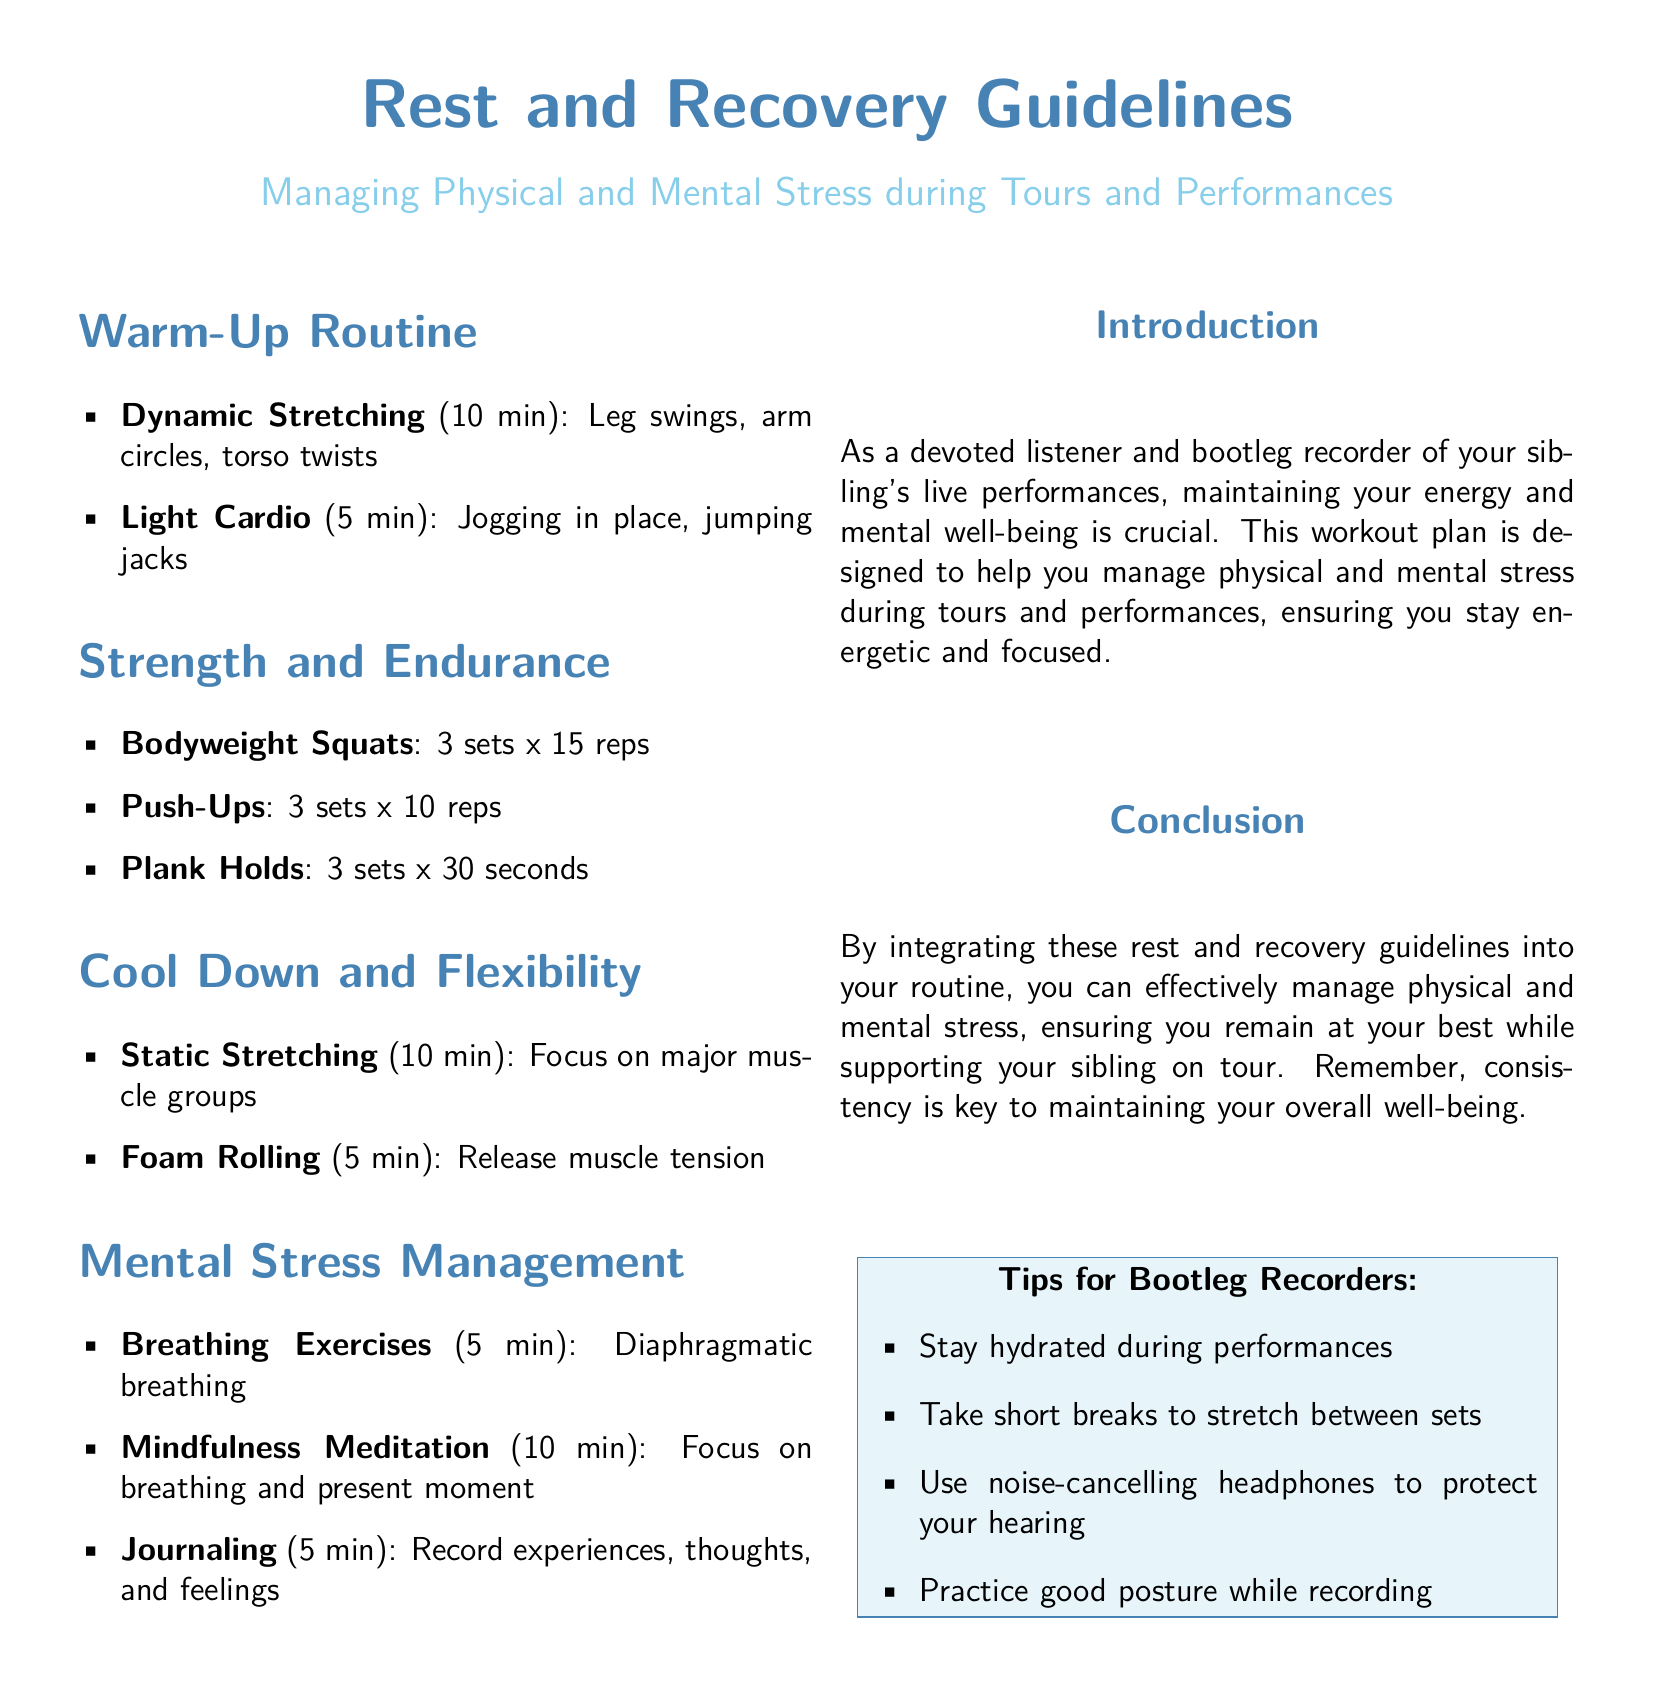What is the total time for the warm-up routine? The warm-up routine consists of 10 minutes for dynamic stretching and 5 minutes for light cardio, totaling 15 minutes.
Answer: 15 min How many sets of bodyweight squats are recommended? The document specifically states to perform 3 sets of bodyweight squats.
Answer: 3 sets What breathing technique is included in mental stress management? Diaphragmatic breathing is highlighted as a breathing technique in the document.
Answer: Diaphragmatic breathing What is a suggested duration for mindfulness meditation? The document suggests practicing mindfulness meditation for 10 minutes.
Answer: 10 min What should bootleg recorders use to protect their hearing? Noise-cancelling headphones are recommended in the tips for bootleg recorders section.
Answer: Noise-cancelling headphones How many minutes are allocated for static stretching in the cool down? The cool down section allocates 10 minutes specifically for static stretching.
Answer: 10 min What type of exercise is suggested after dynamic stretching? Light cardio, such as jogging in place or jumping jacks, follows dynamic stretching in the warm-up routine.
Answer: Light cardio What is the primary focus of the introduction section? The introduction emphasizes the importance of maintaining energy and mental well-being during performances.
Answer: Energy and mental well-being 